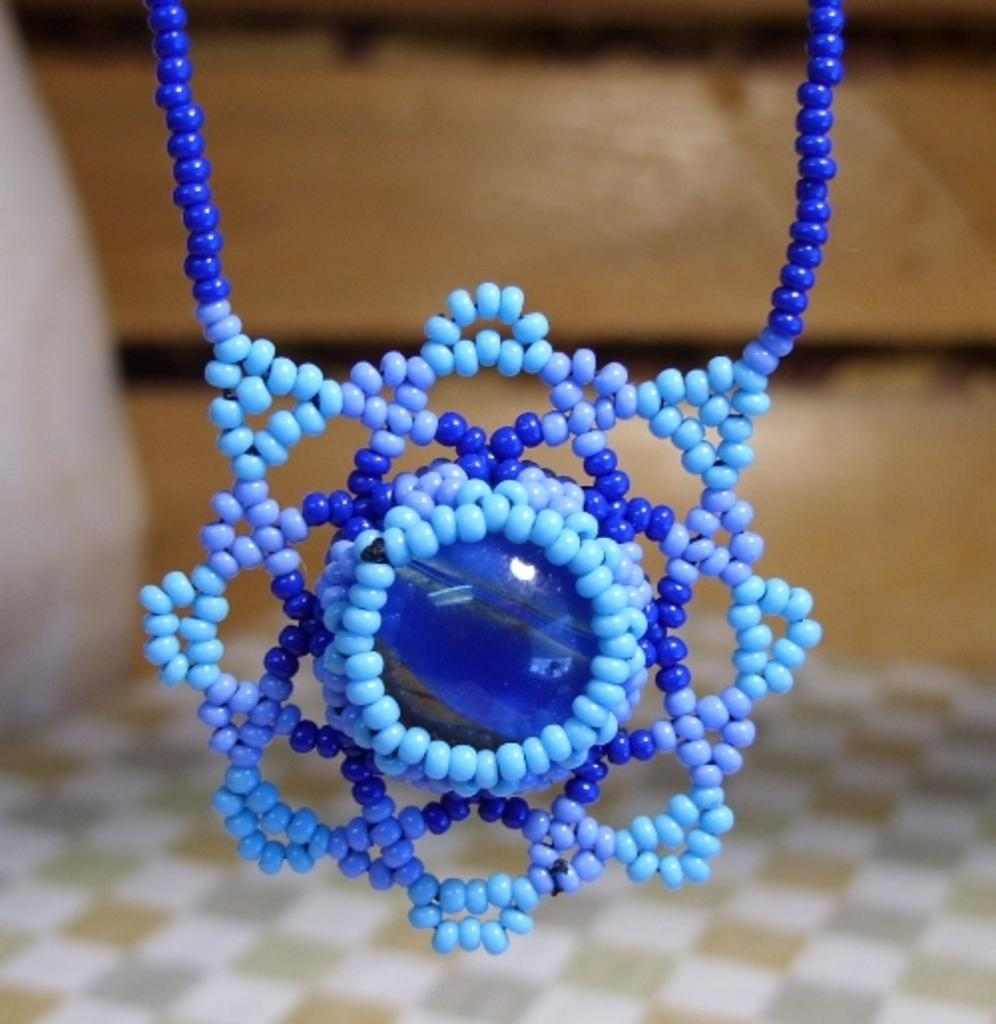What is the main object in the image? The main object in the image is a chain. Can you describe the chain in the image? The chain is in blue color and made of beads. What type of loaf is being used to hold the chain in the image? There is no loaf present in the image; the chain is made of beads and does not require any additional support. 